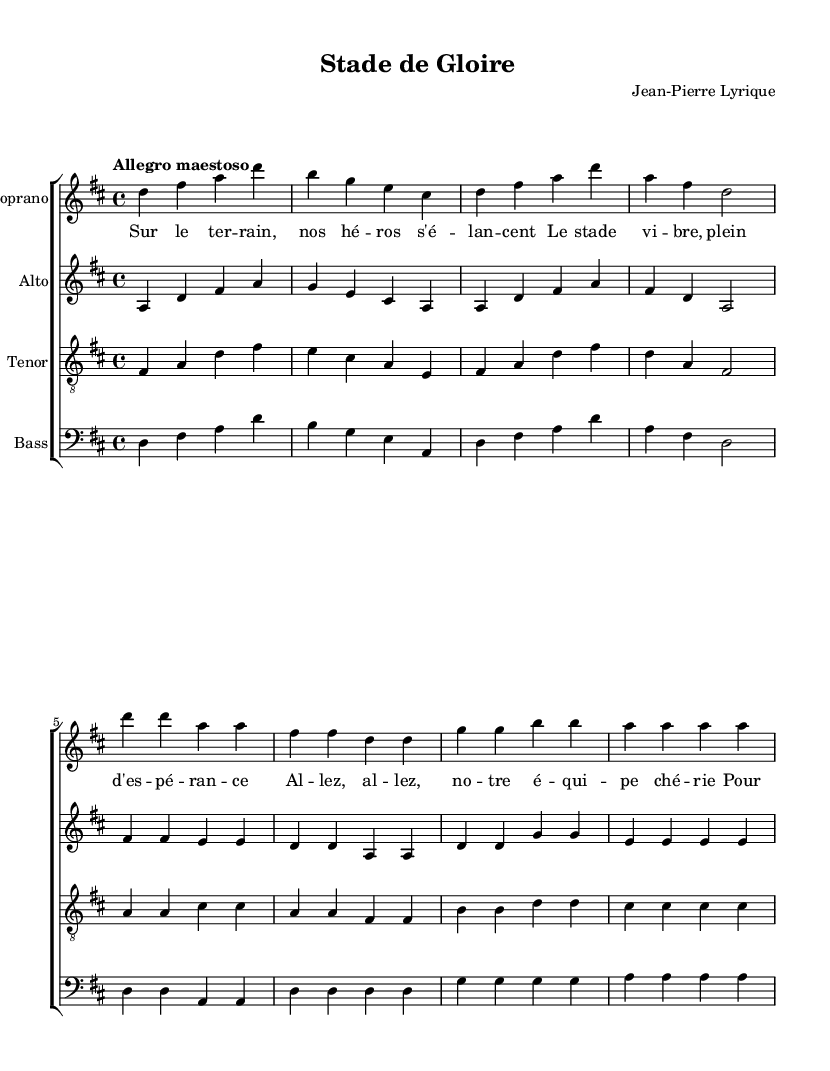What is the key signature of this music? The key signature is D major, which is indicated by two sharps (F# and C#) at the beginning of the staff.
Answer: D major What is the time signature of this piece? The time signature is 4/4, which is indicated by the numbers at the beginning of the staff, allowing four beats per measure.
Answer: 4/4 What is the tempo marking for this piece? The tempo marking is "Allegro maestoso," which indicates a lively and majestic speed for the performance of the piece.
Answer: Allegro maestoso How many voices are present in the score? There are four voices present: soprano, alto, tenor, and bass, as indicated by the separate staves labeled for each voice.
Answer: Four Which section of the score contains lyrics? The lyrics are found beneath the soprano staff, showing the text corresponding to the notes sung by the soprano voice.
Answer: Soprano staff What is the dynamic marking used for the soprano voice? The dynamic marking for the soprano voice is "Up," indicating that the dynamics should be played more prominently above the staff.
Answer: Up What type of musical form does this piece exemplify in operatic music? The piece exemplifies a choral form, as it features a grand chorus that is typical of operatic performances, creating a powerful and unified sound.
Answer: Choral form 